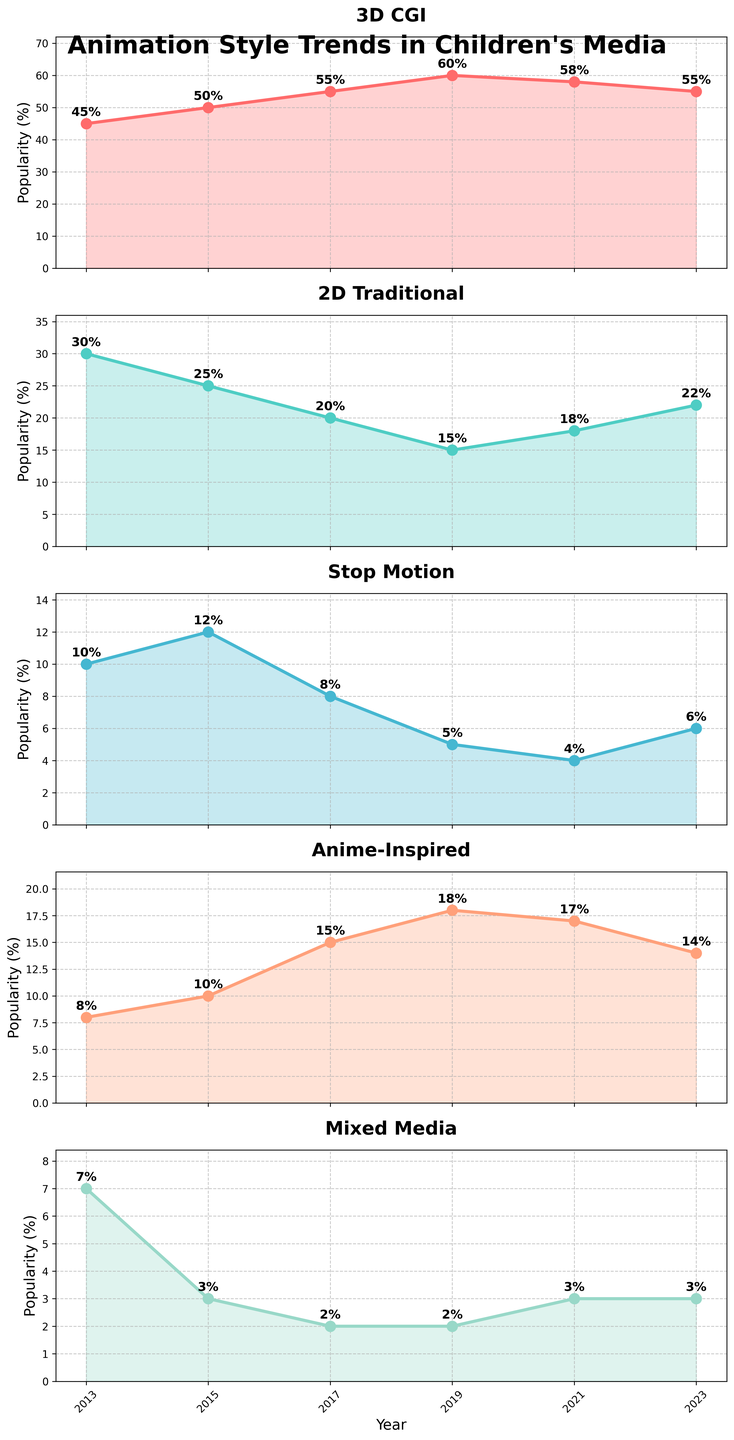What is the title of the figure? The title is generally found at the top of the figure. It summarizes what the figure is about. In this case, it reads "Animation Style Trends in Children's Media".
Answer: Animation Style Trends in Children's Media How many subplots are present in the figure? The subplots are the individual plots stacked vertically. In this figure, there are five distinct subplots, one for each animation style.
Answer: 5 Which animation style was the most popular in 2019? Reference the subplot titles and follow the year 2019 along the x-axis. The ‘3D CGI’ subplot has the highest value in 2019 at 60%.
Answer: 3D CGI What was the lowest popularity percentage for Stop Motion, and in which year did it occur? Look at the 'Stop Motion' subplot and find the year with the lowest percentage. It reached the lowest level of 4% in 2021.
Answer: 4%, 2021 Which year saw the highest popularity for Anime-Inspired animation? Look at the 'Anime-Inspired' subplot and trace the highest point to the corresponding year on the x-axis. The highest value, 18%, occurred in 2019.
Answer: 2019 What was the range of popularity for 2D Traditional animation over the years? The range is the difference between the maximum and minimum values. For '2D Traditional,' the highest value is 30% (2013) and the lowest is 15% (2019), so the range is 30% - 15% = 15%.
Answer: 15% Compare the popularity trends of 3D CGI and Mixed Media in 2023. Which style was more popular? Look at both the '3D CGI' and 'Mixed Media' subplots for the year 2023. '3D CGI' has a value of 55%, while 'Mixed Media' has a value of 3%. Thus, 3D CGI was more popular.
Answer: 3D CGI In which year did Stop Motion and Mixed Media have the same popularity, and what was the percentage? Look at both 'Stop Motion' and 'Mixed Media' subplots and find the year where their values match. In 2019, both had a popularity of 2%.
Answer: 2019, 2% Calculate the average popularity of Anime-Inspired animation over the given years. Sum the percentages for 'Anime-Inspired' across all years (8% + 10% + 15% + 18% + 17% + 14% = 82%) and divide by the number of years (6). The average is 82/6 ≈ 13.67%.
Answer: 13.67% Which animation style showed the most consistent popularity trend over the years? Consistency can be judged by the smallest fluctuations. Reviewing each subplot, 'Mixed Media' shows the least fluctuation, remaining between 2% and 7% throughout the years.
Answer: Mixed Media 